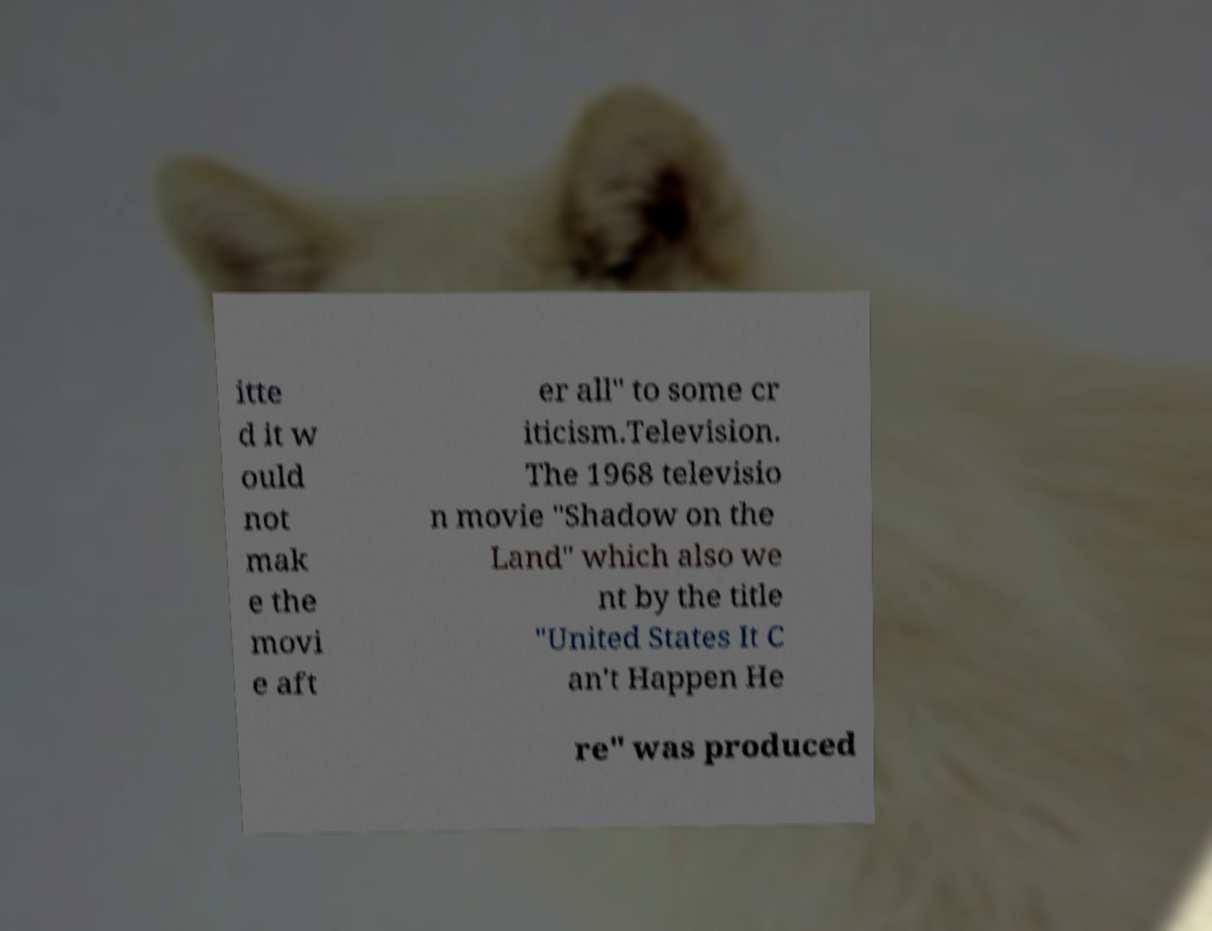Please read and relay the text visible in this image. What does it say? itte d it w ould not mak e the movi e aft er all" to some cr iticism.Television. The 1968 televisio n movie "Shadow on the Land" which also we nt by the title "United States It C an't Happen He re" was produced 